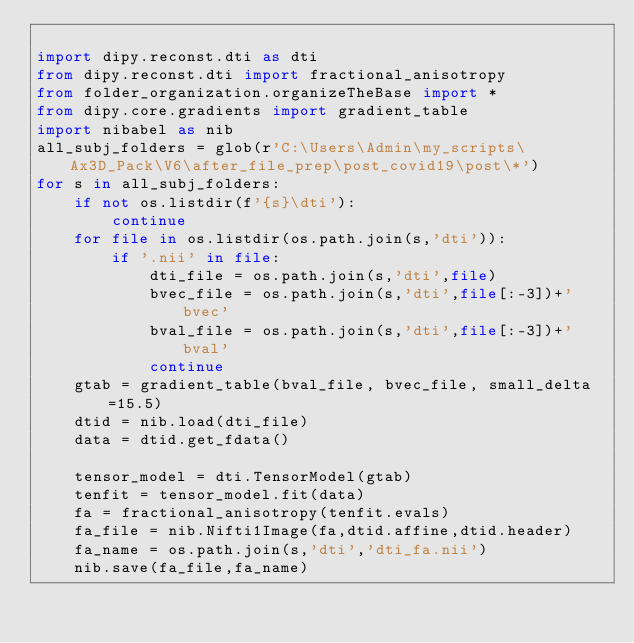Convert code to text. <code><loc_0><loc_0><loc_500><loc_500><_Python_>
import dipy.reconst.dti as dti
from dipy.reconst.dti import fractional_anisotropy
from folder_organization.organizeTheBase import *
from dipy.core.gradients import gradient_table
import nibabel as nib
all_subj_folders = glob(r'C:\Users\Admin\my_scripts\Ax3D_Pack\V6\after_file_prep\post_covid19\post\*')
for s in all_subj_folders:
    if not os.listdir(f'{s}\dti'):
        continue
    for file in os.listdir(os.path.join(s,'dti')):
        if '.nii' in file:
            dti_file = os.path.join(s,'dti',file)
            bvec_file = os.path.join(s,'dti',file[:-3])+'bvec'
            bval_file = os.path.join(s,'dti',file[:-3])+'bval'
            continue
    gtab = gradient_table(bval_file, bvec_file, small_delta=15.5)
    dtid = nib.load(dti_file)
    data = dtid.get_fdata()

    tensor_model = dti.TensorModel(gtab)
    tenfit = tensor_model.fit(data)
    fa = fractional_anisotropy(tenfit.evals)
    fa_file = nib.Nifti1Image(fa,dtid.affine,dtid.header)
    fa_name = os.path.join(s,'dti','dti_fa.nii')
    nib.save(fa_file,fa_name)</code> 